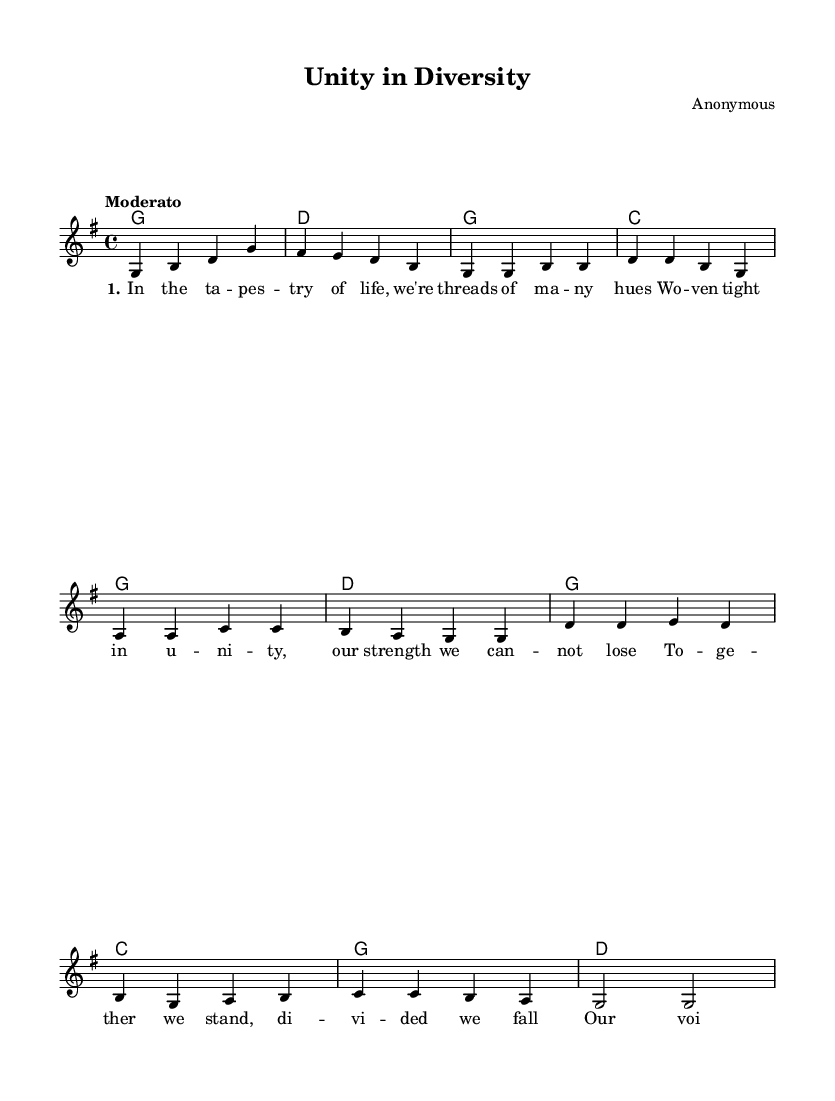What is the key signature of this music? The key signature is G major, which has one sharp (F#) indicated at the beginning of the staff.
Answer: G major What is the time signature of this music? The time signature, represented by the fraction at the beginning of the score, is 4/4, which means four beats per measure and the quarter note gets one beat.
Answer: 4/4 What is the tempo marking for this music? The tempo marking is "Moderato," which indicates a moderate speed, generally around 108–120 beats per minute.
Answer: Moderato How many measures are in the Verse section? The Verse section consists of four measures, counting each set of notes between the bar lines in the melody line.
Answer: 4 What is the first lyric of the chorus? The first lyric of the chorus begins with "d'", as noted in the corresponding lyrics aligned with the melody notes in the score.
Answer: "d'" What chord follows the chorus in the chord progression? The chord progression following the chorus ends with a G chord, as indicated in the harmonies section.
Answer: G Which stanza is indicated in the verse lyrics? The stanza indicated in the verse lyrics is "1," as marked by the 'set stanza' notation at the start of the lyrics.
Answer: 1 